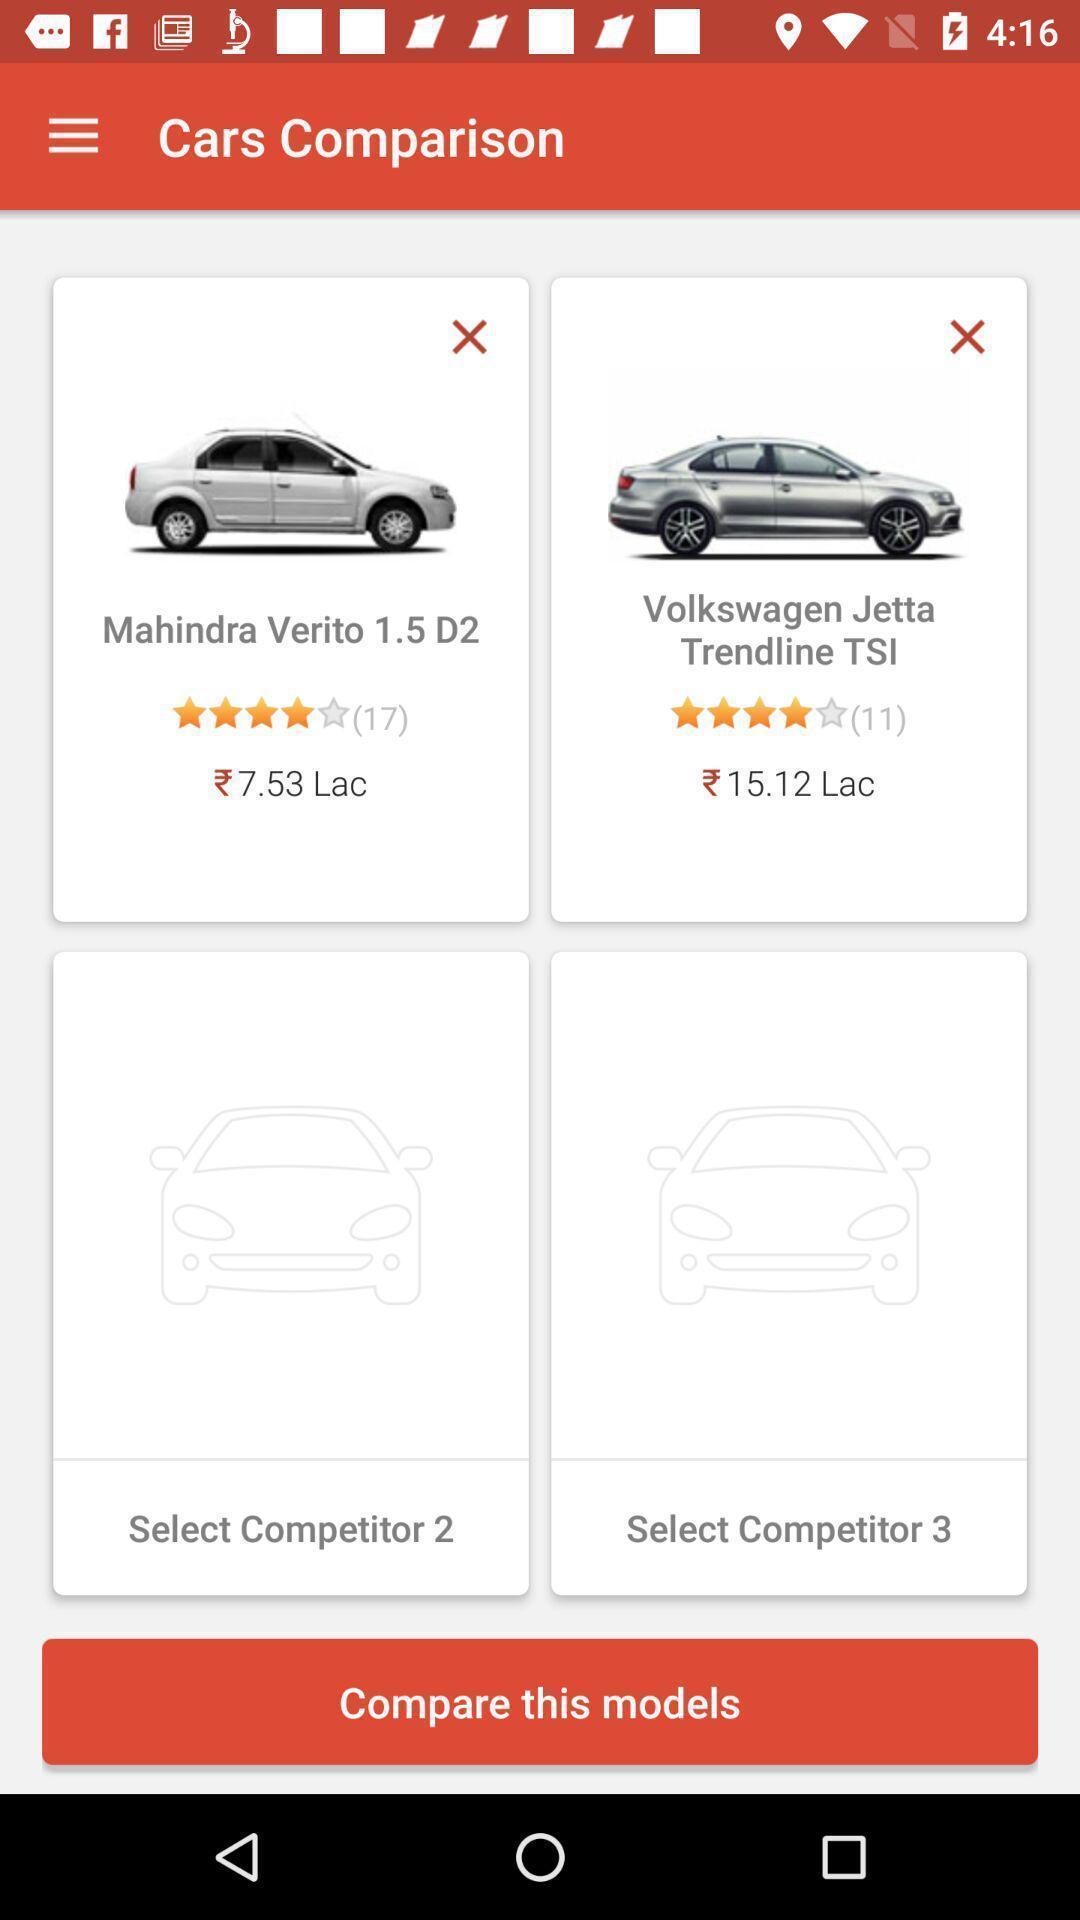Describe the content in this image. Screen shows comparison page in the car application. 